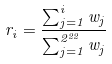<formula> <loc_0><loc_0><loc_500><loc_500>r _ { i } = \frac { \sum _ { j = 1 } ^ { i } w _ { j } } { \sum _ { j = 1 } ^ { 2 ^ { 2 2 } } w _ { j } }</formula> 